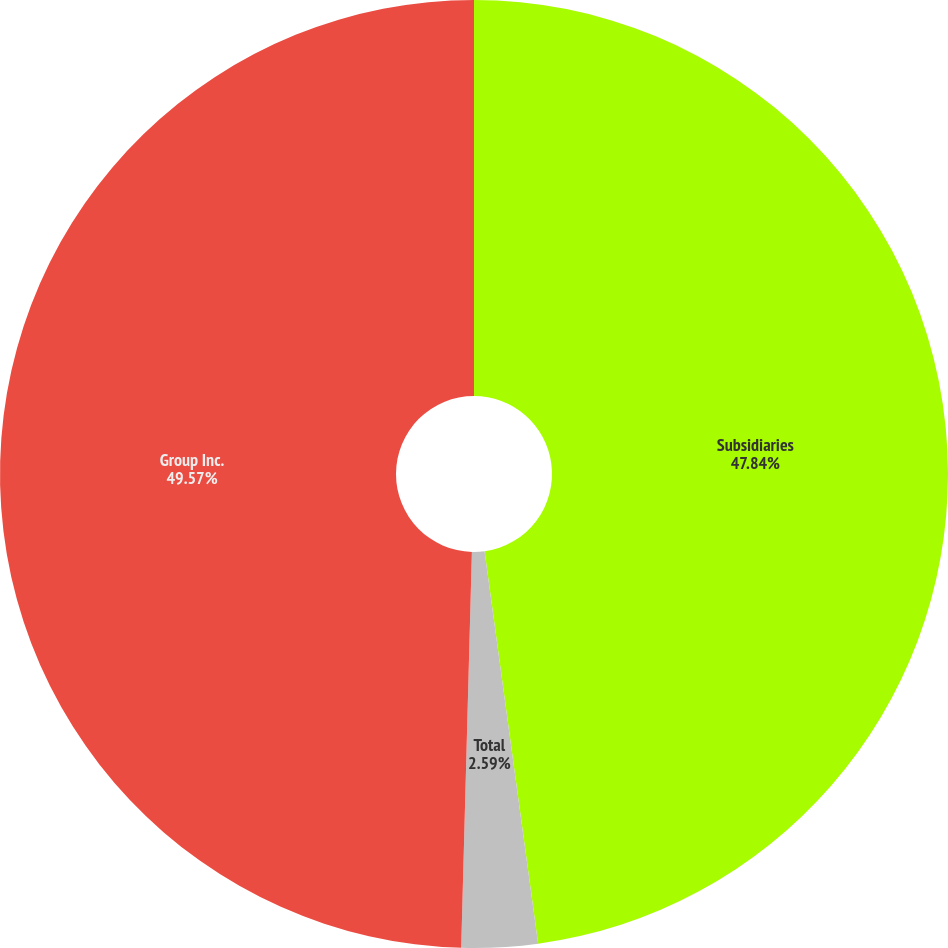<chart> <loc_0><loc_0><loc_500><loc_500><pie_chart><fcel>Subsidiaries<fcel>Total<fcel>Group Inc.<nl><fcel>47.84%<fcel>2.59%<fcel>49.57%<nl></chart> 